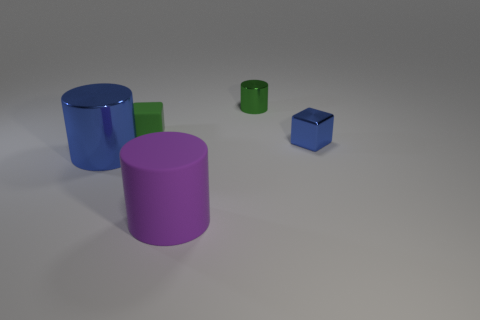Add 3 tiny brown matte cylinders. How many objects exist? 8 Subtract all cylinders. How many objects are left? 2 Add 5 big purple matte cylinders. How many big purple matte cylinders exist? 6 Subtract 1 blue cylinders. How many objects are left? 4 Subtract all small red rubber objects. Subtract all small objects. How many objects are left? 2 Add 1 tiny shiny cylinders. How many tiny shiny cylinders are left? 2 